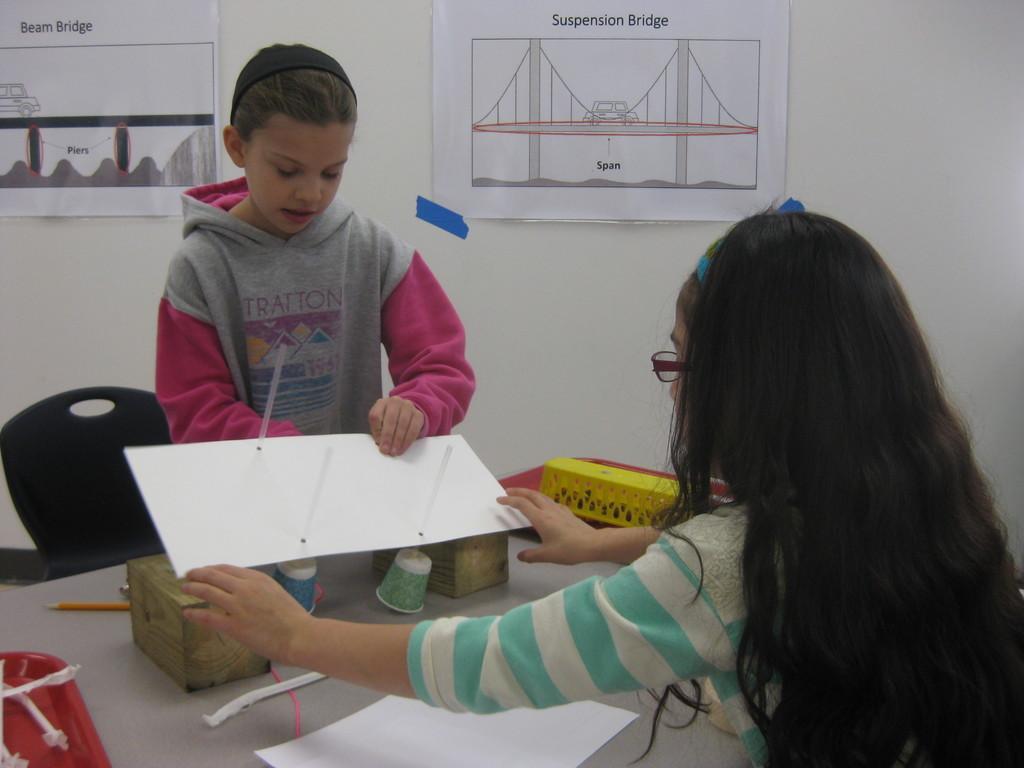Can you describe this image briefly? in this image i can see there are the two persons one person standing wearing a pink color jacket and another person wearing a blue color jacket there are both kept their hands on the table. and there is a drawing on the table and there are cups, pen and there's a chair near to the table. 